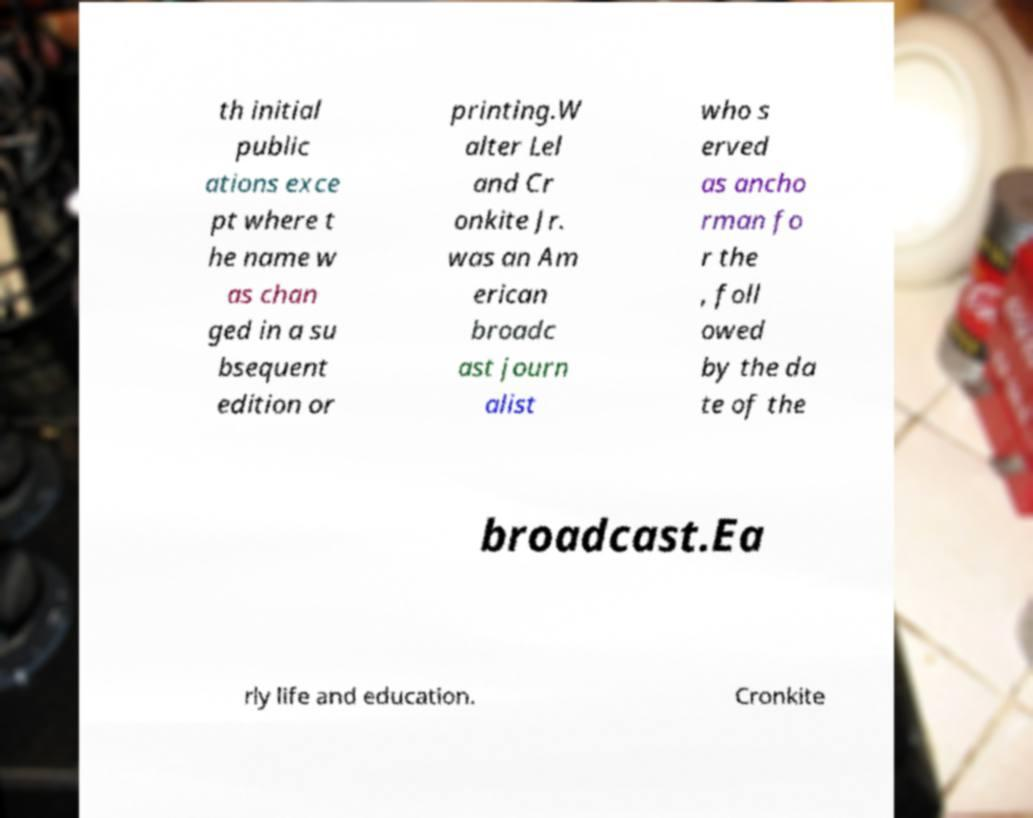Could you extract and type out the text from this image? th initial public ations exce pt where t he name w as chan ged in a su bsequent edition or printing.W alter Lel and Cr onkite Jr. was an Am erican broadc ast journ alist who s erved as ancho rman fo r the , foll owed by the da te of the broadcast.Ea rly life and education. Cronkite 